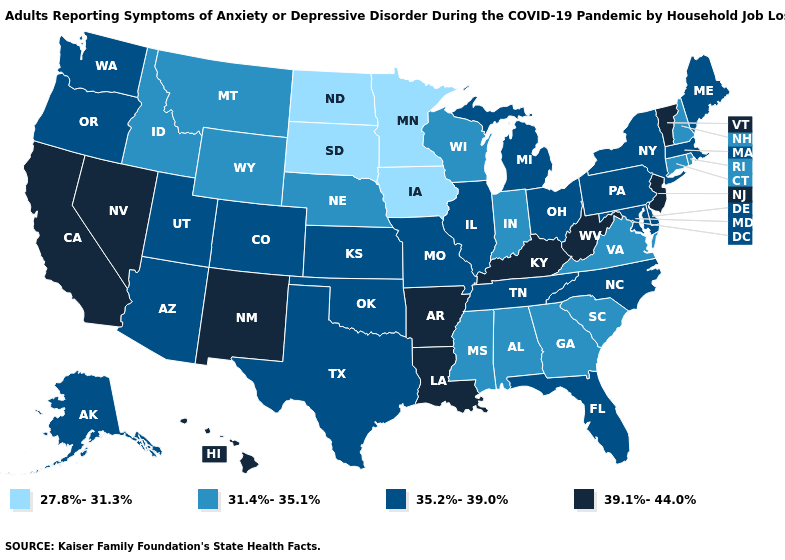Does the first symbol in the legend represent the smallest category?
Answer briefly. Yes. Does Indiana have a lower value than Montana?
Give a very brief answer. No. What is the value of Texas?
Write a very short answer. 35.2%-39.0%. Which states have the highest value in the USA?
Answer briefly. Arkansas, California, Hawaii, Kentucky, Louisiana, Nevada, New Jersey, New Mexico, Vermont, West Virginia. Name the states that have a value in the range 27.8%-31.3%?
Give a very brief answer. Iowa, Minnesota, North Dakota, South Dakota. Name the states that have a value in the range 27.8%-31.3%?
Concise answer only. Iowa, Minnesota, North Dakota, South Dakota. Does the map have missing data?
Write a very short answer. No. Which states hav the highest value in the Northeast?
Concise answer only. New Jersey, Vermont. Does Nevada have the lowest value in the West?
Give a very brief answer. No. Does Texas have the lowest value in the South?
Be succinct. No. Does North Dakota have the same value as Minnesota?
Give a very brief answer. Yes. What is the value of Connecticut?
Concise answer only. 31.4%-35.1%. How many symbols are there in the legend?
Write a very short answer. 4. Which states hav the highest value in the South?
Give a very brief answer. Arkansas, Kentucky, Louisiana, West Virginia. What is the value of Oklahoma?
Give a very brief answer. 35.2%-39.0%. 